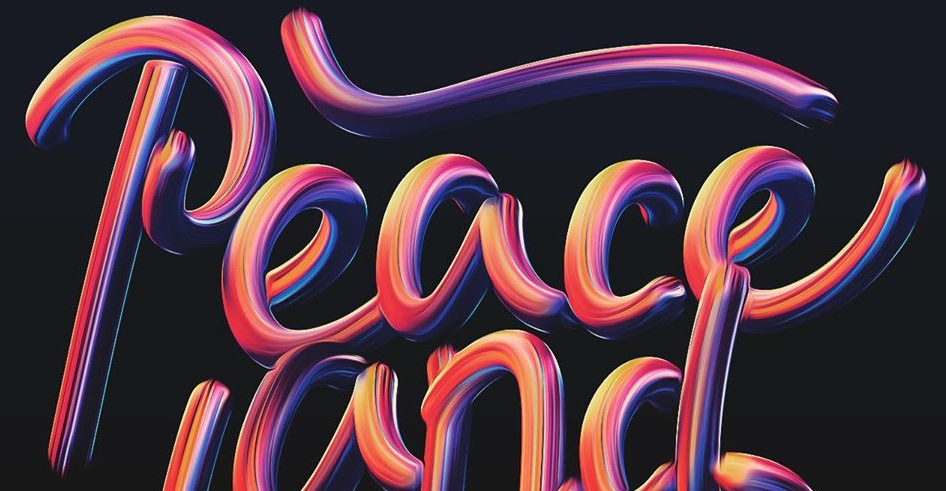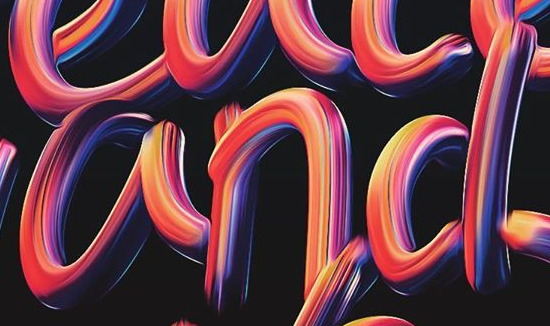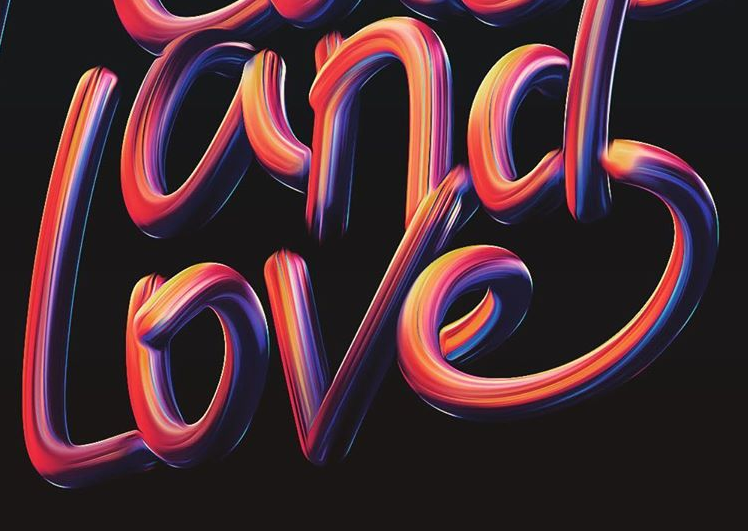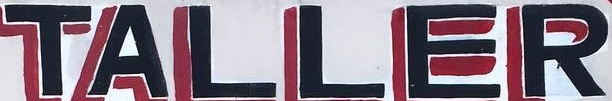What words can you see in these images in sequence, separated by a semicolon? Peace; and; Love; TALLER 